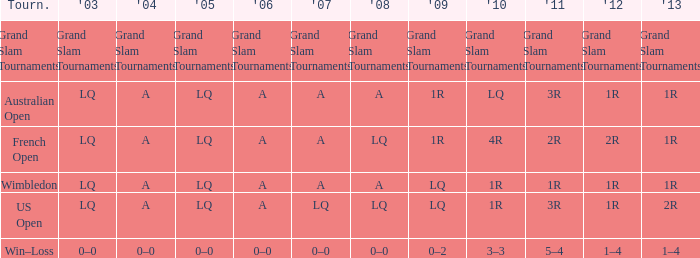Which year has a 2003 of lq? 1R, 1R, LQ, LQ. 